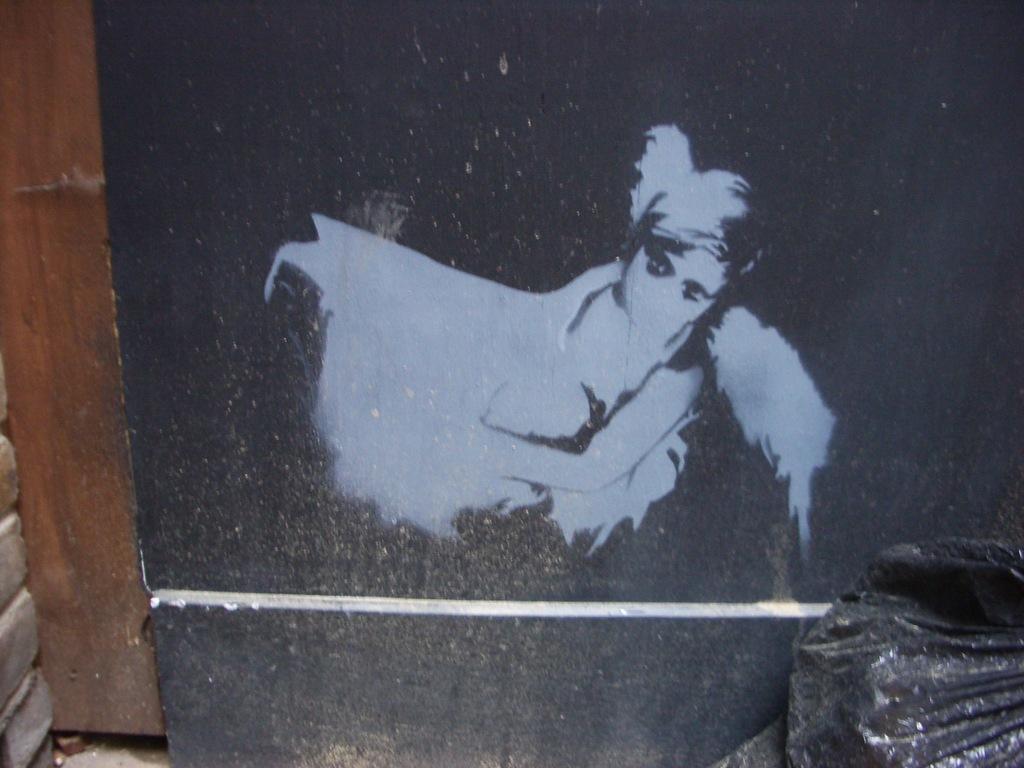Can you describe this image briefly? In this image we can see a painting on an object. There is an object at the right side of the image. 